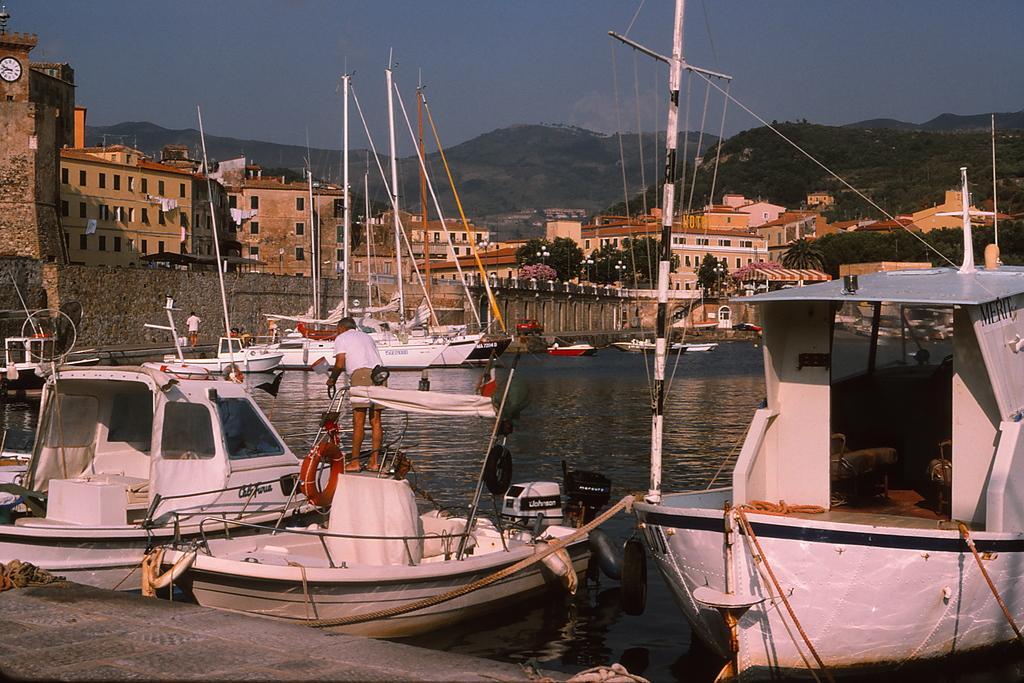What is happening on the water in the image? There are boats on water in the image. What type of structures can be seen in the image? There are buildings with windows in the image. What natural features are present in the image? There are mountains and trees in the image. What is visible in the background of the image? The sky is visible in the background of the image. Where are the oranges being served on a stage in the image? There are no oranges or stage present in the image. What type of game is being played in the image? There is no game being played in the image. 